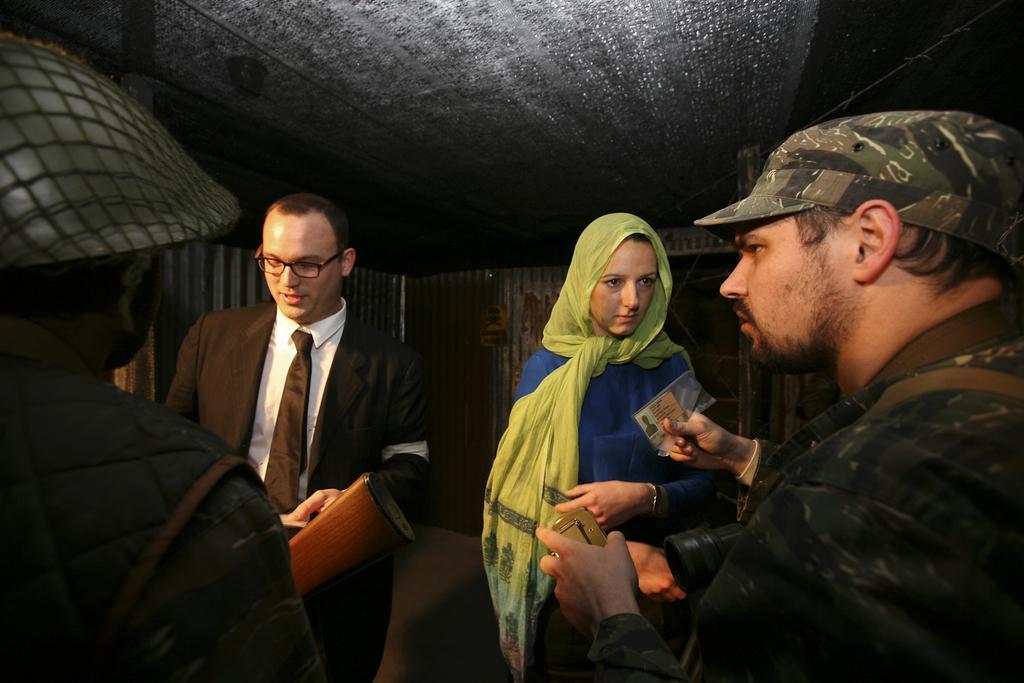Describe this image in one or two sentences. In this image we can see few persons and among them few people are holding objects. Behind the persons we can see a wall and at the top we can see a roof. 